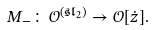Convert formula to latex. <formula><loc_0><loc_0><loc_500><loc_500>M _ { - } \colon \mathcal { O } ^ { ( \mathfrak { s l } _ { 2 } ) } \to \mathcal { O } [ \dot { z } ] .</formula> 